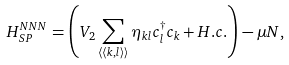Convert formula to latex. <formula><loc_0><loc_0><loc_500><loc_500>H ^ { N N N } _ { S P } = \left ( V _ { 2 } \sum _ { \langle \langle k , l \rangle \rangle } \eta _ { k l } c ^ { \dagger } _ { l } c _ { k } + H . c . \right ) - \mu N ,</formula> 